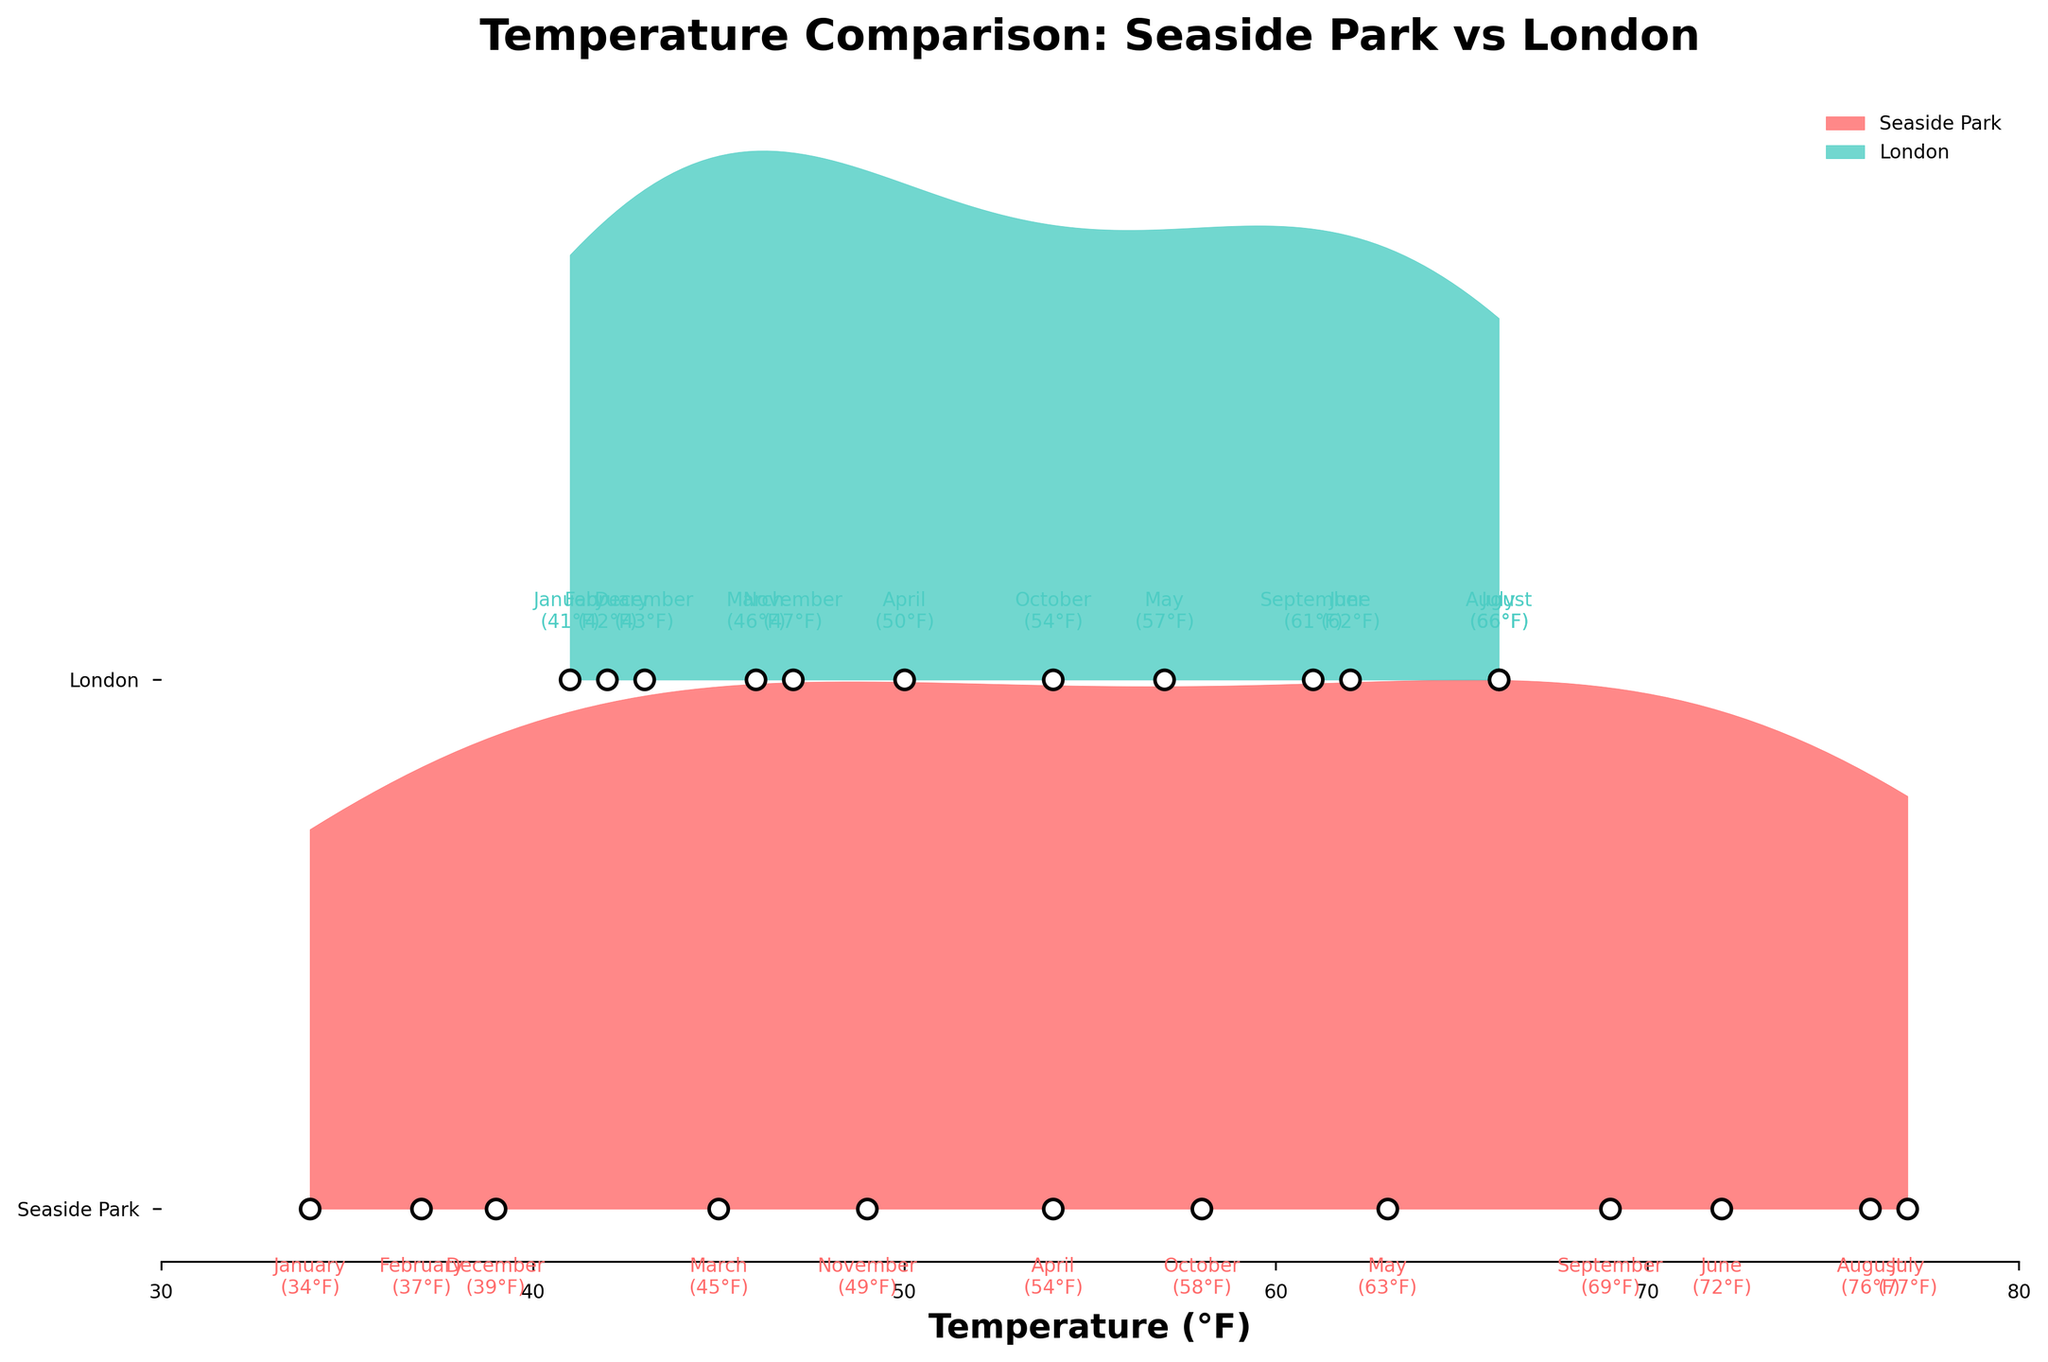What is the highest average temperature in Seaside Park? From the plot, we can see the peak of the Seaside Park ridgeline in July, where the temperature marker indicates 77°F
Answer: 77°F Which month shows the largest temperature difference between Seaside Park and London? The plot annotations show each month's temperatures for both locations. Comparing these, July has Seaside Park at 77°F and London at 66°F, a 11°F difference, which is the largest.
Answer: July How does the average temperature in Seaside Park in December compare to London in the same month? In December, the temperature annotations indicate Seaside Park at 39°F and London at 43°F, showing that Seaside Park is 4°F colder.
Answer: Seaside Park is 4°F colder What is the general trend of temperatures from January to December in Seaside Park? Observing the plotted points along the ridgeline from left (January) to right (December), the temperatures start low, peak around July, and then decrease again towards December
Answer: Increases to July, then decreases Which location has higher average temperatures in April? The plot shows an April label with 54°F for Seaside Park and 50°F for London
Answer: Seaside Park During which month are temperatures in Seaside Park and London closest to each other? The plot annotations show the least difference visually during March, with Seaside Park at 45°F and London at 46°F, only 1°F apart
Answer: March Across all months, which location shows more variability in temperatures? In the plot, the variation in vertical positions of points on the Seaside Park line is larger than on the London line, indicating greater variability in Seaside Park.
Answer: Seaside Park What is the average temperature in London during the summer months (June, July, August)? For London, add June (62°F), July (66°F), and August (66°F), then divide by 3: (62 + 66 + 66) / 3 = 64.67°F
Answer: 64.67°F In which month does Seaside Park experience its lowest average temperature? From the plot, January has the lowest point on the Seaside Park line, at 34°F
Answer: January 